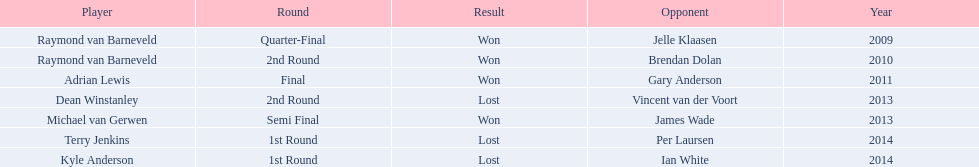What was the names of all the players? Raymond van Barneveld, Raymond van Barneveld, Adrian Lewis, Dean Winstanley, Michael van Gerwen, Terry Jenkins, Kyle Anderson. What years were the championship offered? 2009, 2010, 2011, 2013, 2013, 2014, 2014. Of these, who played in 2011? Adrian Lewis. 